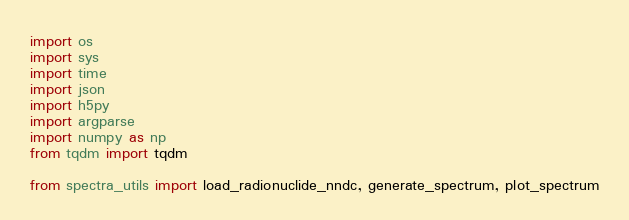<code> <loc_0><loc_0><loc_500><loc_500><_Python_>import os
import sys
import time
import json
import h5py
import argparse
import numpy as np
from tqdm import tqdm

from spectra_utils import load_radionuclide_nndc, generate_spectrum, plot_spectrum

</code> 